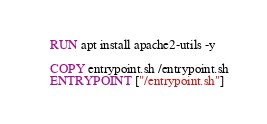Convert code to text. <code><loc_0><loc_0><loc_500><loc_500><_Dockerfile_>RUN apt install apache2-utils -y

COPY entrypoint.sh /entrypoint.sh
ENTRYPOINT ["/entrypoint.sh"]
</code> 